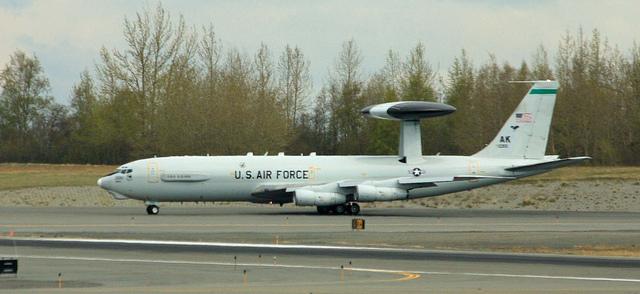What three letters are on the tail of the plane?
Be succinct. Ak. Is this the president's plane?
Short answer required. No. Do you see an American flag?
Give a very brief answer. Yes. What does it say on the side of the plane?
Keep it brief. Us air force. 